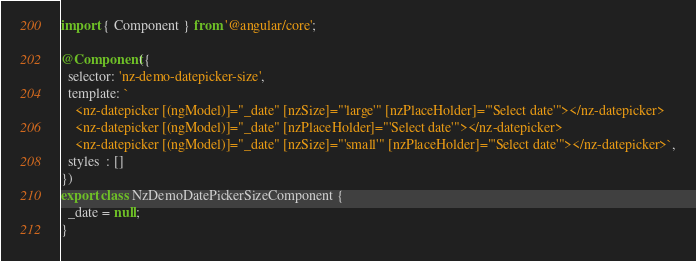<code> <loc_0><loc_0><loc_500><loc_500><_TypeScript_>import { Component } from '@angular/core';

@Component({
  selector: 'nz-demo-datepicker-size',
  template: `
    <nz-datepicker [(ngModel)]="_date" [nzSize]="'large'" [nzPlaceHolder]="'Select date'"></nz-datepicker>
    <nz-datepicker [(ngModel)]="_date" [nzPlaceHolder]="'Select date'"></nz-datepicker>
    <nz-datepicker [(ngModel)]="_date" [nzSize]="'small'" [nzPlaceHolder]="'Select date'"></nz-datepicker>`,
  styles  : []
})
export class NzDemoDatePickerSizeComponent {
  _date = null;
}
</code> 